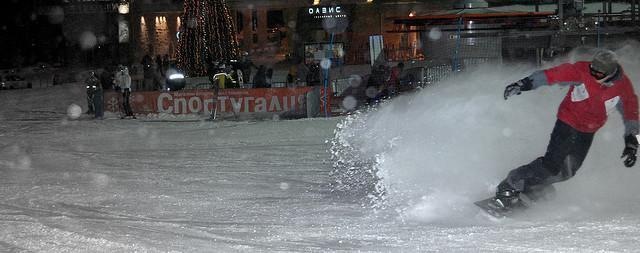How many people can you see?
Give a very brief answer. 1. How many zebras are in this picture?
Give a very brief answer. 0. 